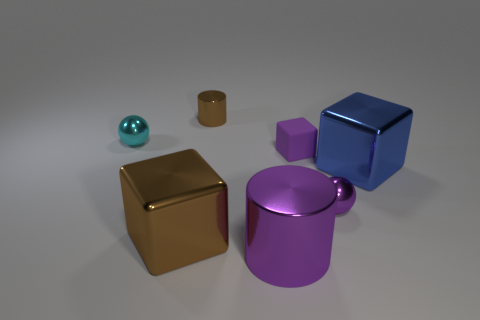Subtract all brown cubes. How many cubes are left? 2 Add 2 blue balls. How many objects exist? 9 Subtract all brown cubes. How many cubes are left? 2 Subtract all spheres. How many objects are left? 5 Add 5 tiny green cylinders. How many tiny green cylinders exist? 5 Subtract 0 brown spheres. How many objects are left? 7 Subtract 1 balls. How many balls are left? 1 Subtract all cyan blocks. Subtract all cyan balls. How many blocks are left? 3 Subtract all large brown cylinders. Subtract all small brown things. How many objects are left? 6 Add 6 tiny brown metal objects. How many tiny brown metal objects are left? 7 